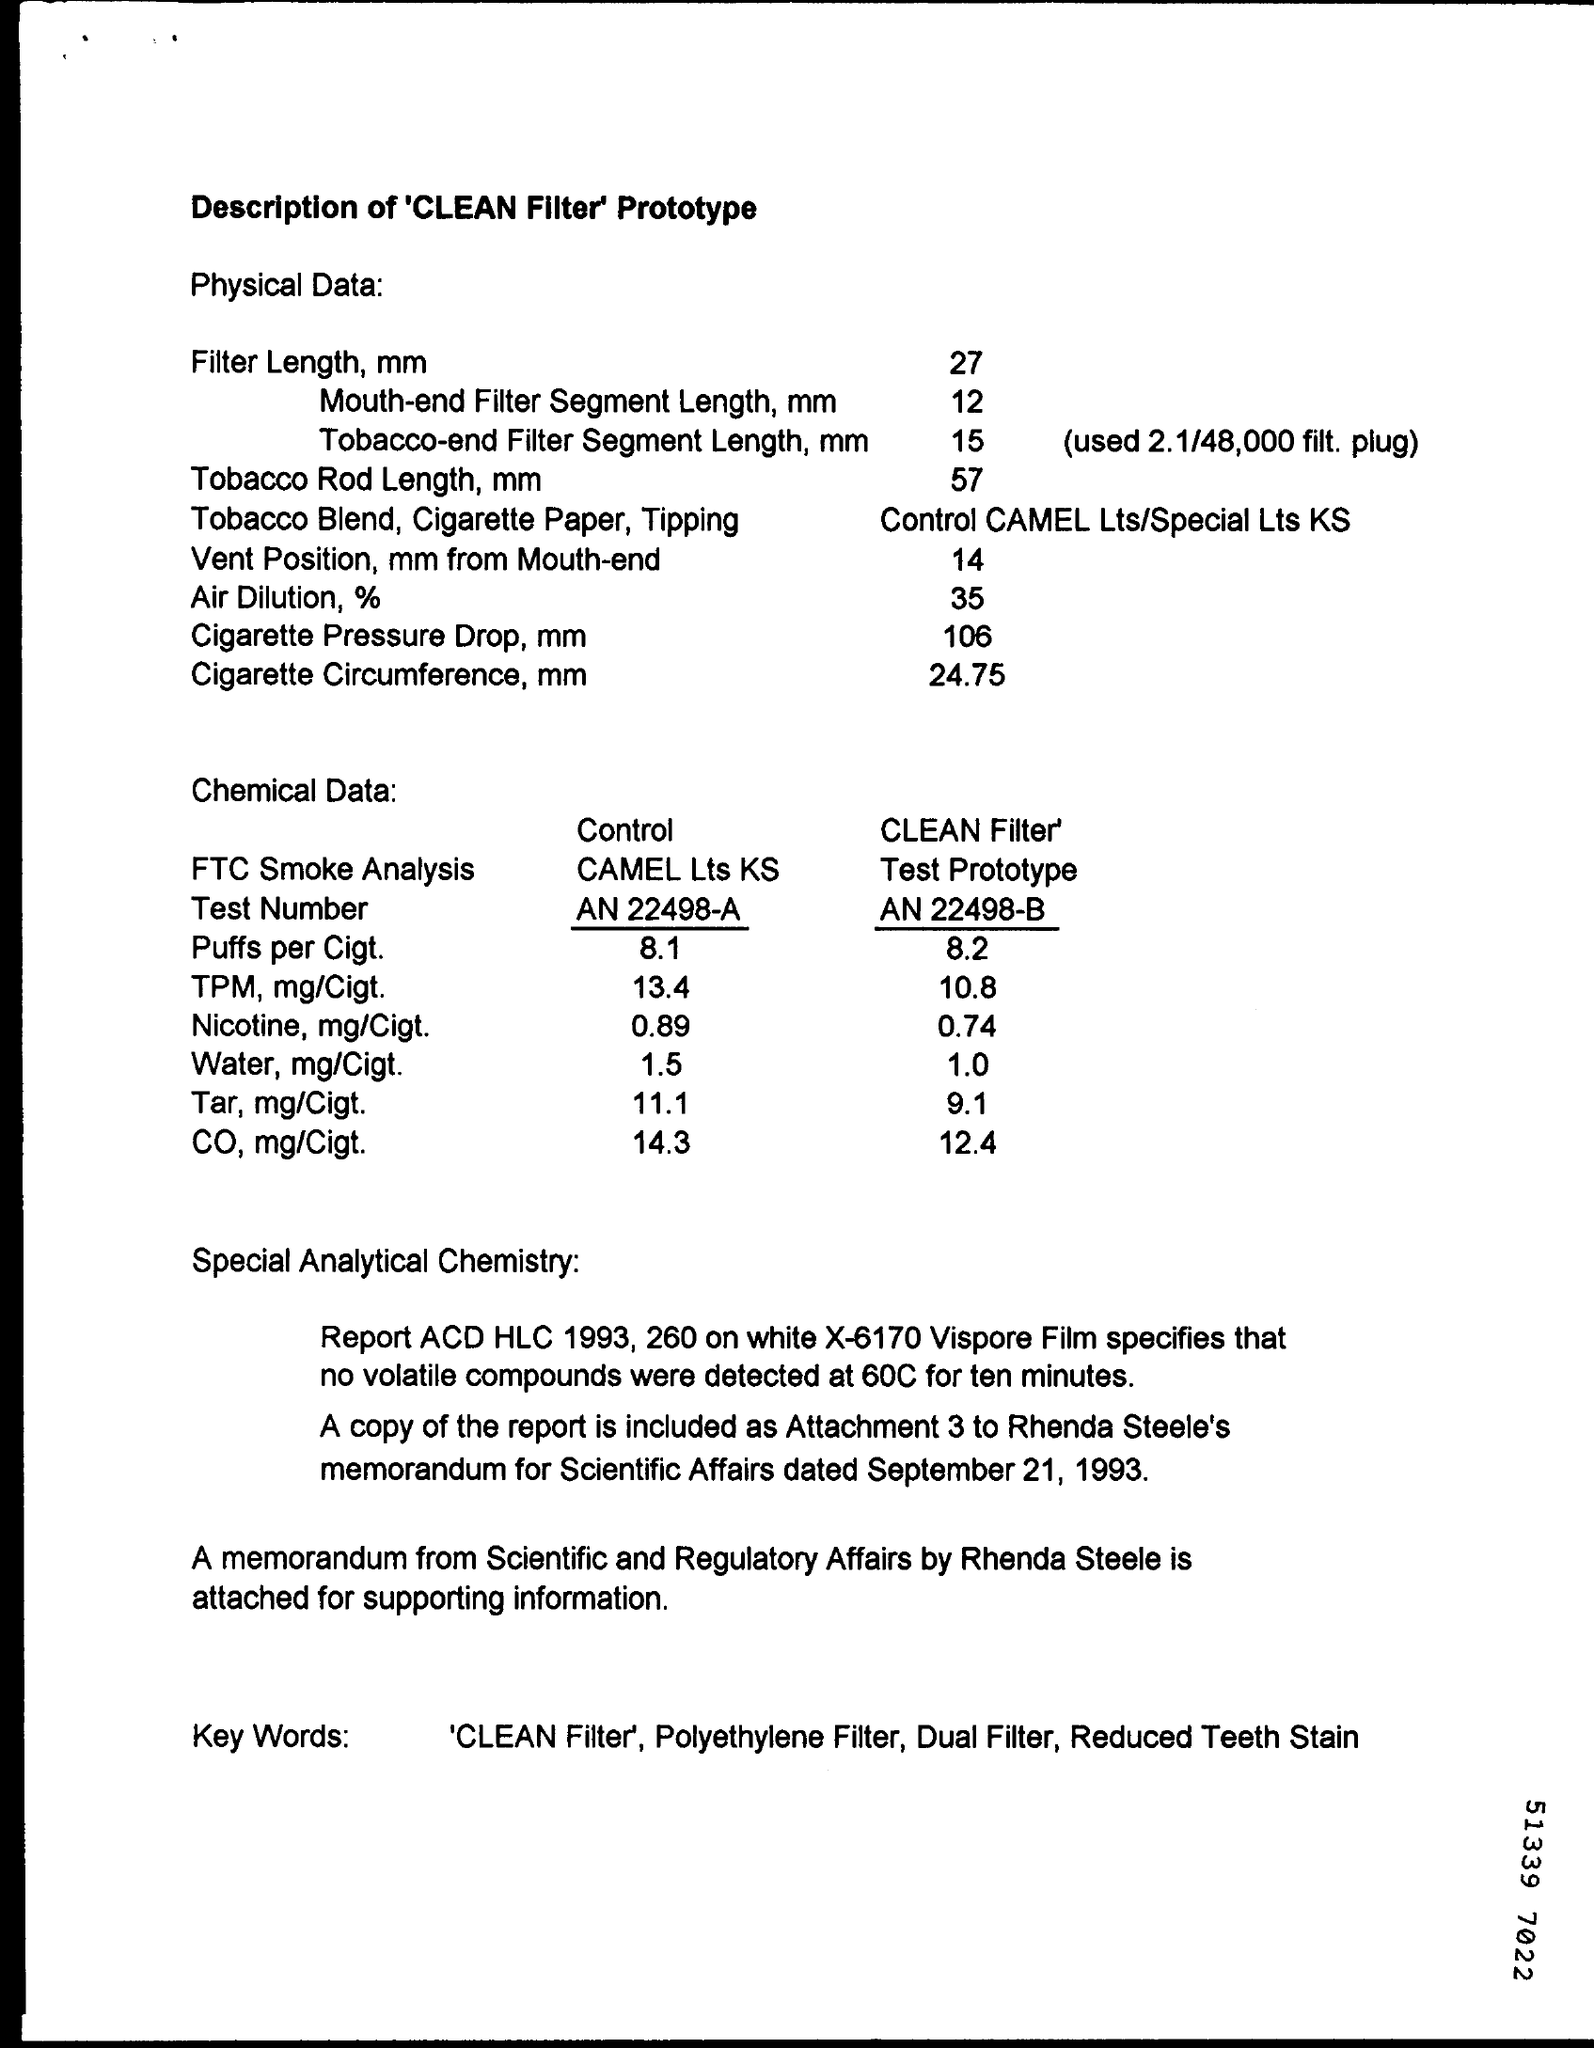What is the document title?
Make the answer very short. Description of 'CLEAN filter' Prototype. What is the filter length in mm?
Offer a very short reply. 27. What is the Cigarette Circumference in mm?
Your answer should be compact. 24.75. What is the amount of CO, mg/Cigt. in CLEAN Filter Test Prototype?
Provide a succinct answer. 12.4. A memorandum by who is attached?
Your answer should be compact. Rhenda steele. What is the Test Number of Control CAMEL Lts Ks?
Your answer should be compact. AN 22498-A. 